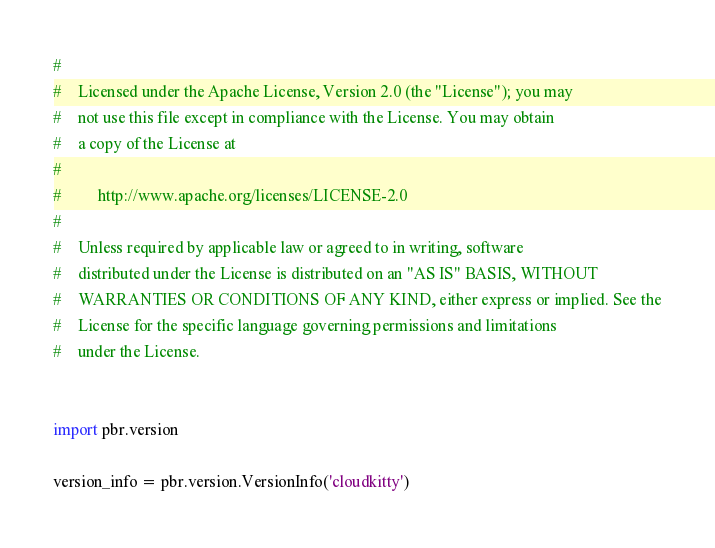<code> <loc_0><loc_0><loc_500><loc_500><_Python_>#
#    Licensed under the Apache License, Version 2.0 (the "License"); you may
#    not use this file except in compliance with the License. You may obtain
#    a copy of the License at
#
#         http://www.apache.org/licenses/LICENSE-2.0
#
#    Unless required by applicable law or agreed to in writing, software
#    distributed under the License is distributed on an "AS IS" BASIS, WITHOUT
#    WARRANTIES OR CONDITIONS OF ANY KIND, either express or implied. See the
#    License for the specific language governing permissions and limitations
#    under the License.


import pbr.version

version_info = pbr.version.VersionInfo('cloudkitty')
</code> 